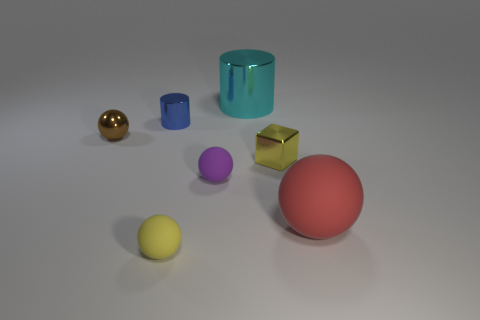Add 3 small yellow shiny cubes. How many objects exist? 10 Subtract all cylinders. How many objects are left? 5 Add 5 tiny cylinders. How many tiny cylinders are left? 6 Add 3 large brown cylinders. How many large brown cylinders exist? 3 Subtract 0 red cubes. How many objects are left? 7 Subtract all tiny yellow cubes. Subtract all tiny purple things. How many objects are left? 5 